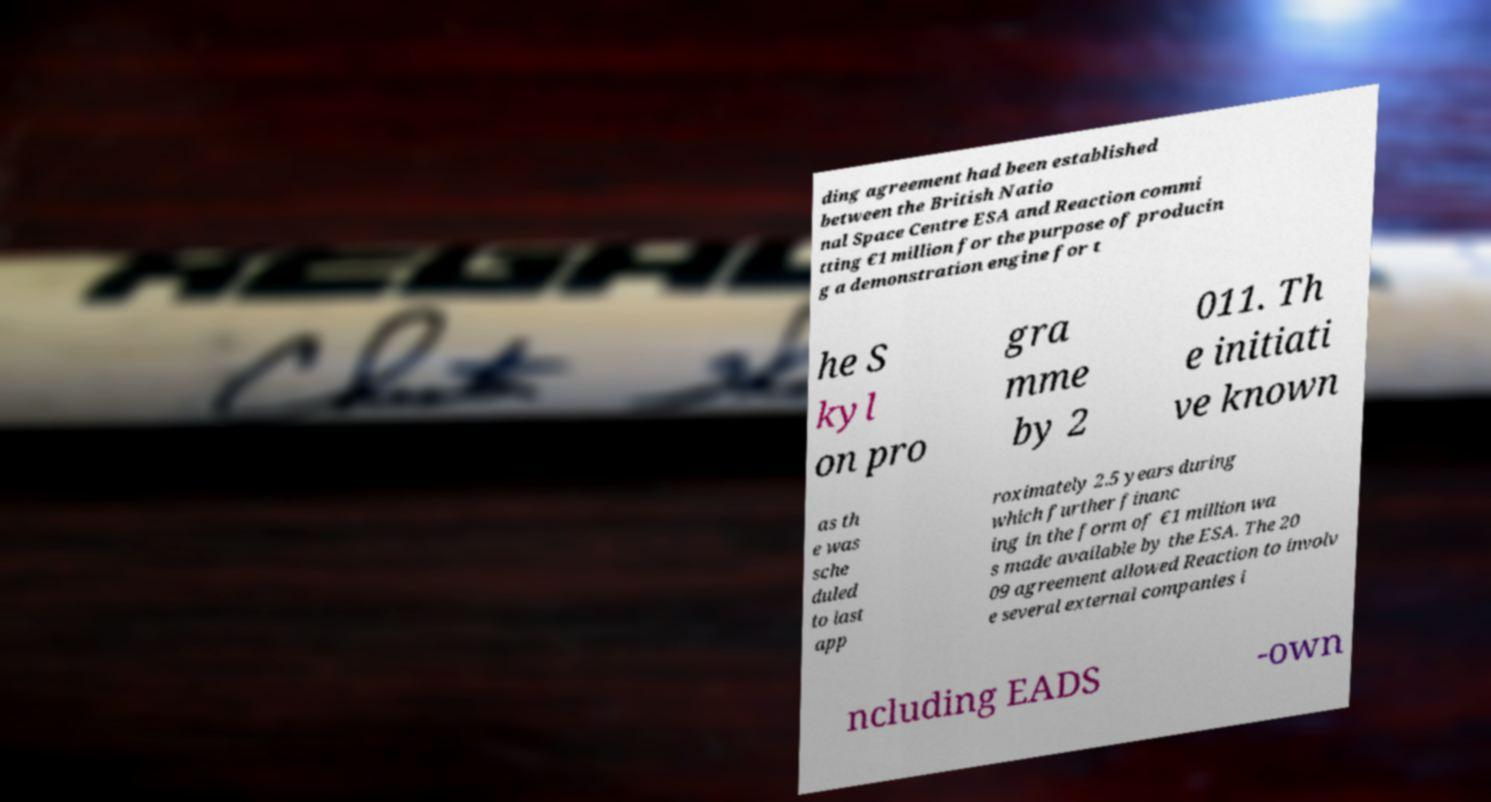Please identify and transcribe the text found in this image. ding agreement had been established between the British Natio nal Space Centre ESA and Reaction commi tting €1 million for the purpose of producin g a demonstration engine for t he S kyl on pro gra mme by 2 011. Th e initiati ve known as th e was sche duled to last app roximately 2.5 years during which further financ ing in the form of €1 million wa s made available by the ESA. The 20 09 agreement allowed Reaction to involv e several external companies i ncluding EADS -own 